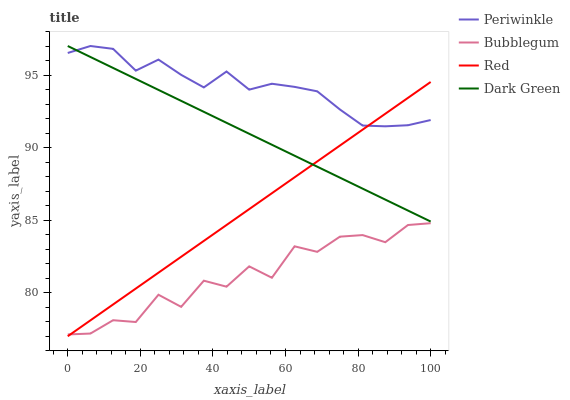Does Bubblegum have the minimum area under the curve?
Answer yes or no. Yes. Does Periwinkle have the maximum area under the curve?
Answer yes or no. Yes. Does Red have the minimum area under the curve?
Answer yes or no. No. Does Red have the maximum area under the curve?
Answer yes or no. No. Is Dark Green the smoothest?
Answer yes or no. Yes. Is Bubblegum the roughest?
Answer yes or no. Yes. Is Red the smoothest?
Answer yes or no. No. Is Red the roughest?
Answer yes or no. No. Does Red have the lowest value?
Answer yes or no. Yes. Does Bubblegum have the lowest value?
Answer yes or no. No. Does Dark Green have the highest value?
Answer yes or no. Yes. Does Red have the highest value?
Answer yes or no. No. Is Bubblegum less than Periwinkle?
Answer yes or no. Yes. Is Periwinkle greater than Bubblegum?
Answer yes or no. Yes. Does Periwinkle intersect Red?
Answer yes or no. Yes. Is Periwinkle less than Red?
Answer yes or no. No. Is Periwinkle greater than Red?
Answer yes or no. No. Does Bubblegum intersect Periwinkle?
Answer yes or no. No. 